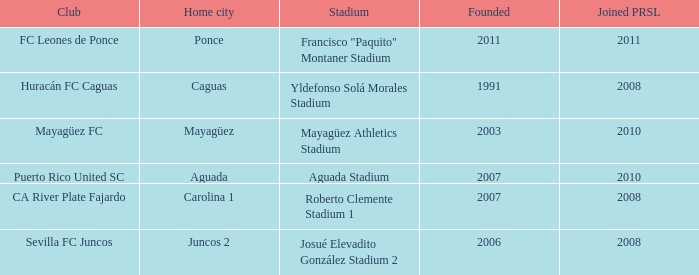What is the earliest inception when the home city is mayagüez? 2003.0. 